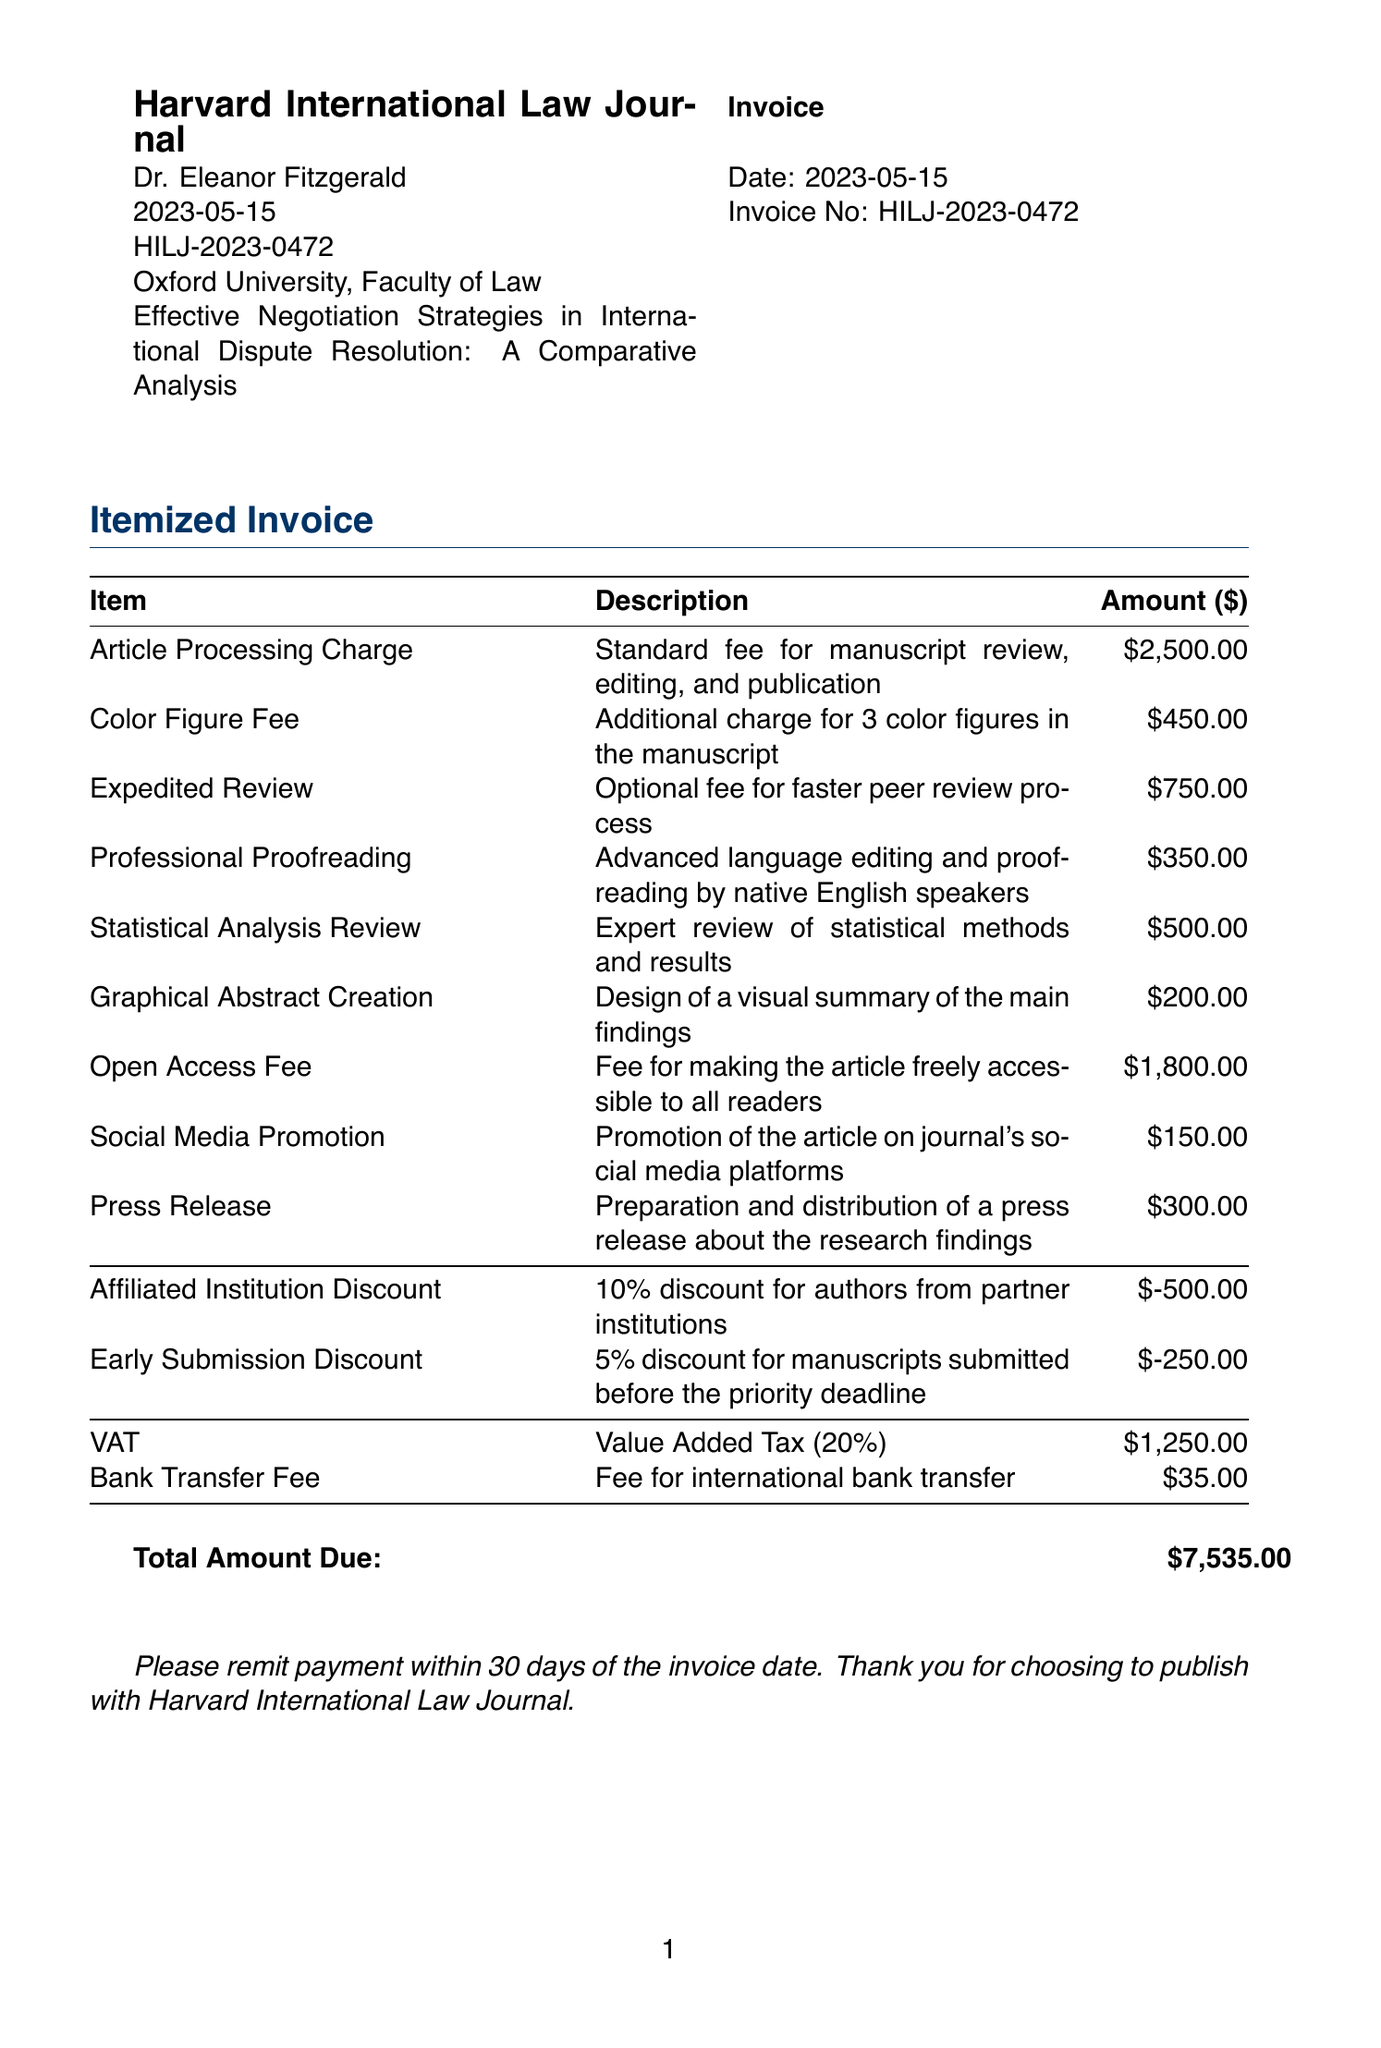what is the journal name? The journal name is clearly stated at the top of the invoice under the invoice header.
Answer: Harvard International Law Journal who is the author? The author name is mentioned in the invoice details, specifying who wrote the academic paper.
Answer: Dr. Eleanor Fitzgerald what is the total amount due? The total amount due is summarized at the end of the invoice.
Answer: $7,535.00 what fee is charged for expedited review? The expedited review fee is listed in the publication fees section, indicating the cost for this service.
Answer: 750.00 what discount is applied for affiliated institution? One discount listed in the invoice specifically mentions benefits for authors from partner institutions.
Answer: 10% discount how many color figures does the manuscript include? The itemized fees detail the specific charges, including the number of color figures in the manuscript.
Answer: 3 what is the due date for payment? The invoice states a payment period in the closing section, providing guidance on payment timelines.
Answer: 30 days what is the VAT amount applied? The VAT amount is included as a separate line item in the taxes and fees section of the document.
Answer: 1,250.00 what type of document is this? The structure and content indicated suggest the purpose of the document.
Answer: Invoice 